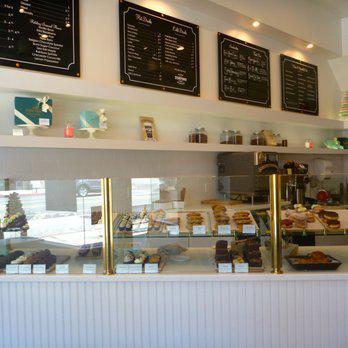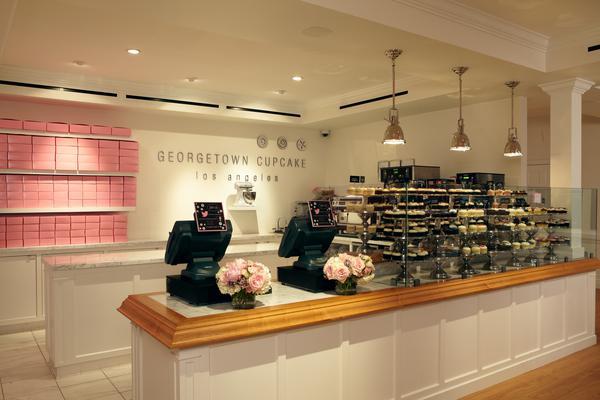The first image is the image on the left, the second image is the image on the right. Assess this claim about the two images: "There is a lampshade that says """"Vanilla Bake Shop""""". Correct or not? Answer yes or no. No. The first image is the image on the left, the second image is the image on the right. For the images shown, is this caption "A large table lamp is on top of a brown table next to a display of desserts." true? Answer yes or no. No. 